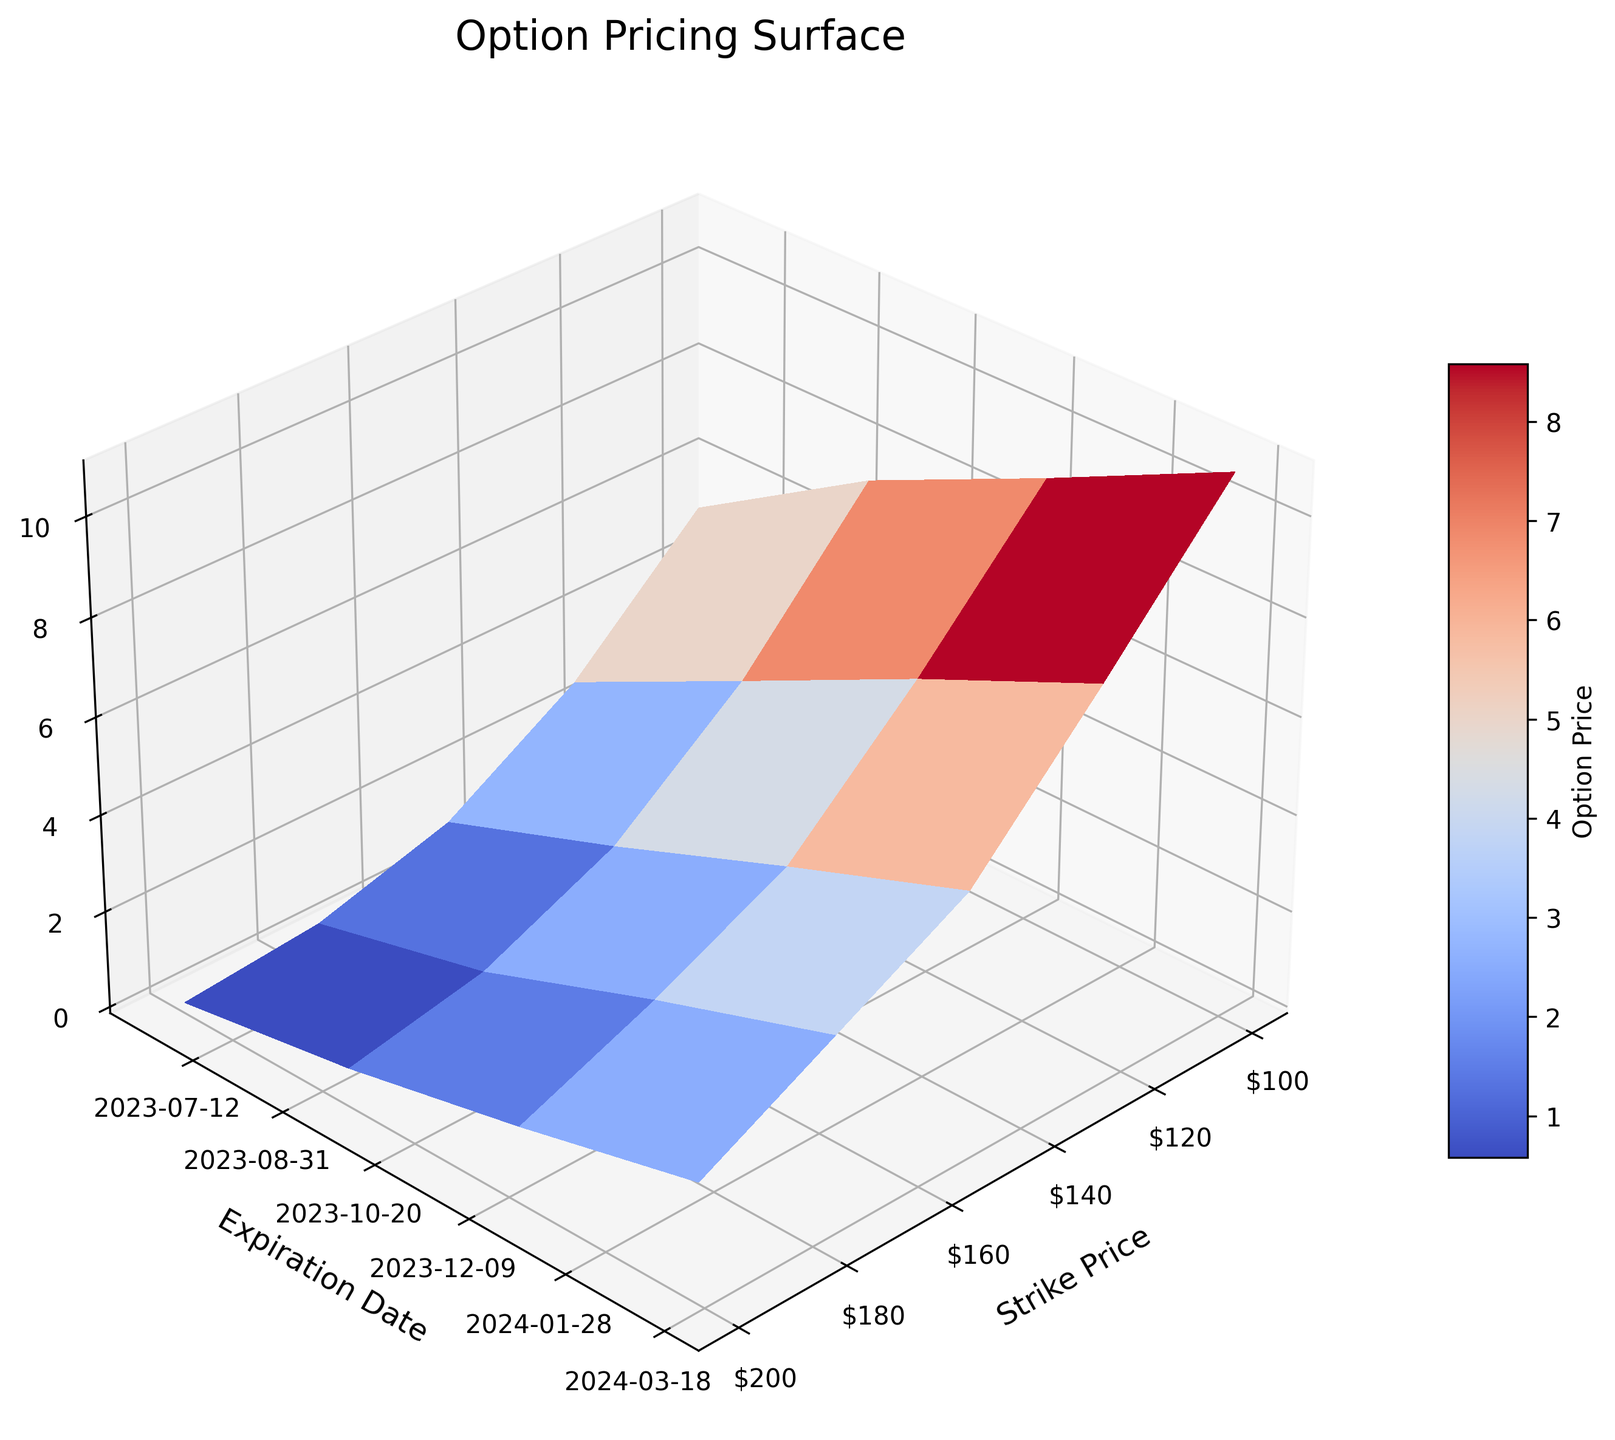What is the title of the plot? The title of the plot is typically located at the top of the figure and indicates the main subject of the visualization.
Answer: Option Pricing Surface What are the labels for the x, y, and z axes? Axis labels provide context for understanding the data dimensions. The x-axis is labeled 'Strike Price', the y-axis is labeled 'Expiration Date', and the z-axis is labeled 'Option Price'.
Answer: Strike Price, Expiration Date, Option Price What color scheme is used for the surface plot? The color scheme helps in differentiating the range of values in the plot. The figure uses the 'coolwarm' colormap, which generally transitions from blue (cool) to red (warm).
Answer: coolwarm How does the option price change with increasing strike prices for a fixed expiration date? Observing a specific expiration date, option prices generally decrease as the strike price increases, which suggests that higher strike prices lead to lower option values. For instance, on 2023-06-15, option prices drop from 5.23 at a strike price of 100 to 0.09 at a strike price of 200.
Answer: Decreases Which strike price consistently shows the highest option prices? By observing the color gradient on the surface plot and comparing the z-values, the strike price of 100 consistently shows the highest option prices across all expiration dates.
Answer: 100 Compare the option prices for strike prices 100 and 150 on the expiration date 2023-12-15. By locating the specific date along the y-axis and comparing the z-values at strike prices 100 and 150, you can see that for 2023-12-15, the prices are 9.12 and 3.87, respectively. Thus, 100 has a higher option price than 150.
Answer: 9.12 vs. 3.87 Which expiration date seems to have the steepest increase in option price as the strike price decreases? Looking for the most pronounced gradient change along the x-axis for different y-values, 2023-03-15 shows the steepest increase in option price as the strike price decreases. This is observable as the most intense color change in that slice of the surface plot.
Answer: 2024-03-15 How does the option price vary over time for a fixed strike price of 125? Fixing the strike price at 125 and observing the changes along the y-axis (expiration date), the option price increases over time; for instance, values are 2.78 on 2023-06-15, 4.56 on 2023-09-15, 6.34 on 2023-12-15, and 7.98 on 2024-03-15.
Answer: Increases What is the range of option prices for strike price 175 across all expiration dates? By observing the z-values for the strike price of 175 across different y-values, the option prices range from 0.34 to 3.78.
Answer: 0.34 to 3.78 Does the surface plot indicate any significant pattern or trend in option pricing over time and different strike prices? By analyzing the 3D structure and color gradients of the surface plot, the pattern indicates that option prices generally increase over time (y-axis) and decrease as the strike price (x-axis) increases. This can be inferred from the gradient of colors from cooler to warmer as time progresses and strike prices decrease.
Answer: Yes, prices increase over time and decrease with increasing strike prices 